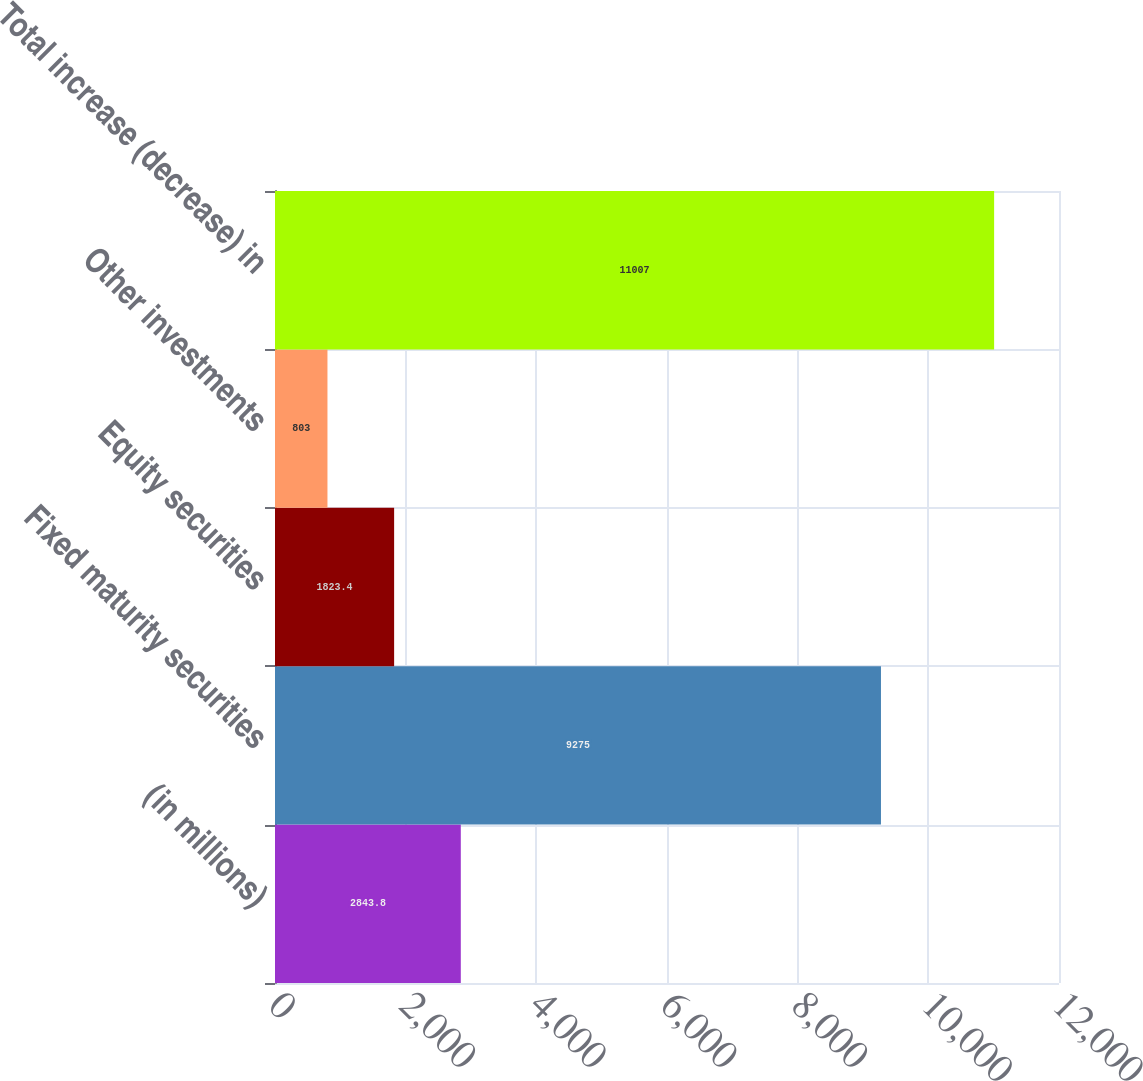<chart> <loc_0><loc_0><loc_500><loc_500><bar_chart><fcel>(in millions)<fcel>Fixed maturity securities<fcel>Equity securities<fcel>Other investments<fcel>Total increase (decrease) in<nl><fcel>2843.8<fcel>9275<fcel>1823.4<fcel>803<fcel>11007<nl></chart> 